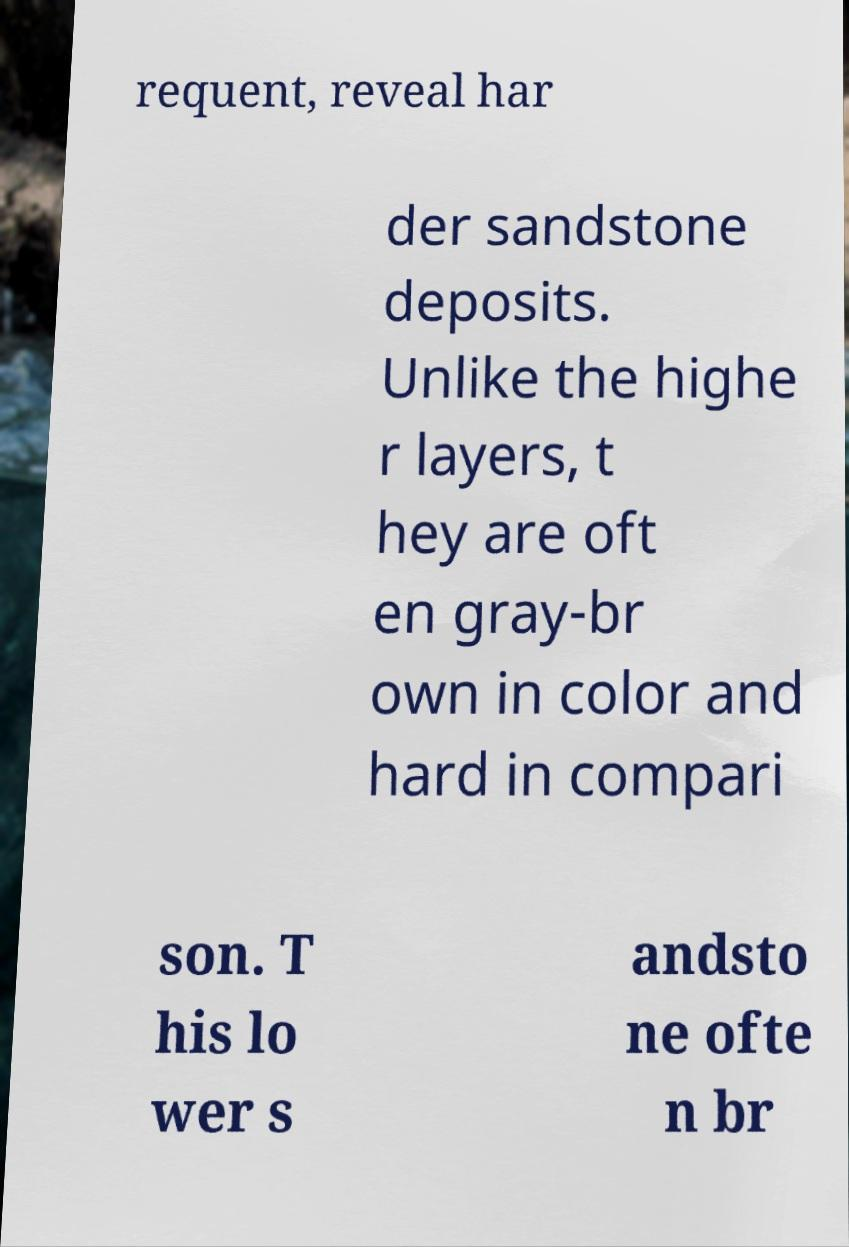What messages or text are displayed in this image? I need them in a readable, typed format. requent, reveal har der sandstone deposits. Unlike the highe r layers, t hey are oft en gray-br own in color and hard in compari son. T his lo wer s andsto ne ofte n br 